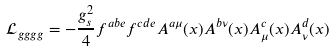Convert formula to latex. <formula><loc_0><loc_0><loc_500><loc_500>\mathcal { L } _ { g g g g } = - \frac { g _ { s } ^ { 2 } } { 4 } f ^ { a b e } f ^ { c d e } { A ^ { a \mu } } ( x ) { A ^ { b \nu } } ( x ) { A _ { \mu } ^ { c } } ( x ) { A _ { \nu } ^ { d } } ( x )</formula> 